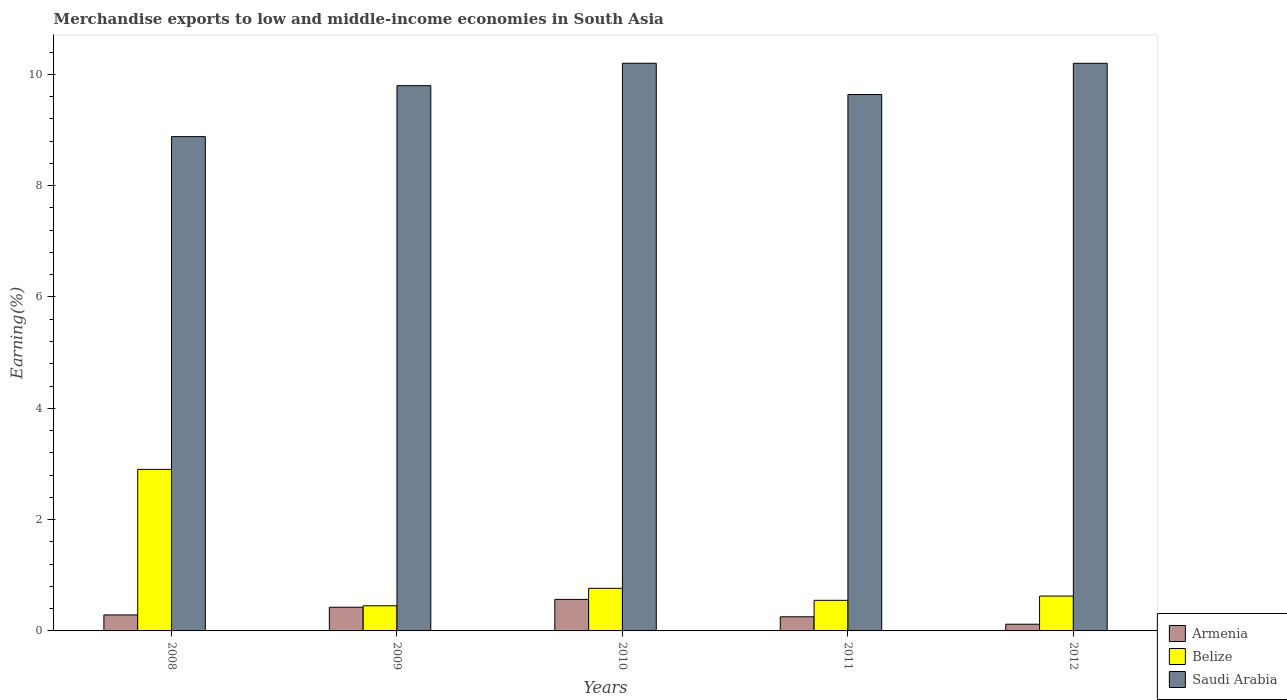Are the number of bars on each tick of the X-axis equal?
Offer a terse response. Yes. What is the label of the 3rd group of bars from the left?
Your answer should be compact. 2010. In how many cases, is the number of bars for a given year not equal to the number of legend labels?
Give a very brief answer. 0. What is the percentage of amount earned from merchandise exports in Saudi Arabia in 2008?
Make the answer very short. 8.88. Across all years, what is the maximum percentage of amount earned from merchandise exports in Armenia?
Give a very brief answer. 0.57. Across all years, what is the minimum percentage of amount earned from merchandise exports in Saudi Arabia?
Your answer should be compact. 8.88. What is the total percentage of amount earned from merchandise exports in Saudi Arabia in the graph?
Ensure brevity in your answer.  48.71. What is the difference between the percentage of amount earned from merchandise exports in Belize in 2009 and that in 2011?
Your answer should be compact. -0.1. What is the difference between the percentage of amount earned from merchandise exports in Armenia in 2010 and the percentage of amount earned from merchandise exports in Saudi Arabia in 2012?
Offer a very short reply. -9.63. What is the average percentage of amount earned from merchandise exports in Belize per year?
Provide a succinct answer. 1.06. In the year 2008, what is the difference between the percentage of amount earned from merchandise exports in Armenia and percentage of amount earned from merchandise exports in Saudi Arabia?
Provide a succinct answer. -8.59. What is the ratio of the percentage of amount earned from merchandise exports in Armenia in 2010 to that in 2011?
Your answer should be compact. 2.23. Is the percentage of amount earned from merchandise exports in Saudi Arabia in 2009 less than that in 2011?
Your response must be concise. No. What is the difference between the highest and the second highest percentage of amount earned from merchandise exports in Saudi Arabia?
Keep it short and to the point. 0. What is the difference between the highest and the lowest percentage of amount earned from merchandise exports in Belize?
Offer a terse response. 2.45. What does the 3rd bar from the left in 2011 represents?
Provide a succinct answer. Saudi Arabia. What does the 3rd bar from the right in 2009 represents?
Give a very brief answer. Armenia. Are all the bars in the graph horizontal?
Offer a terse response. No. Does the graph contain any zero values?
Give a very brief answer. No. Does the graph contain grids?
Your answer should be compact. No. Where does the legend appear in the graph?
Your answer should be very brief. Bottom right. How many legend labels are there?
Ensure brevity in your answer.  3. How are the legend labels stacked?
Offer a terse response. Vertical. What is the title of the graph?
Offer a terse response. Merchandise exports to low and middle-income economies in South Asia. Does "Slovak Republic" appear as one of the legend labels in the graph?
Your answer should be very brief. No. What is the label or title of the X-axis?
Give a very brief answer. Years. What is the label or title of the Y-axis?
Give a very brief answer. Earning(%). What is the Earning(%) in Armenia in 2008?
Keep it short and to the point. 0.29. What is the Earning(%) of Belize in 2008?
Offer a very short reply. 2.9. What is the Earning(%) of Saudi Arabia in 2008?
Provide a short and direct response. 8.88. What is the Earning(%) in Armenia in 2009?
Provide a succinct answer. 0.43. What is the Earning(%) of Belize in 2009?
Offer a very short reply. 0.45. What is the Earning(%) of Saudi Arabia in 2009?
Provide a succinct answer. 9.8. What is the Earning(%) in Armenia in 2010?
Your response must be concise. 0.57. What is the Earning(%) in Belize in 2010?
Give a very brief answer. 0.77. What is the Earning(%) of Saudi Arabia in 2010?
Your answer should be compact. 10.2. What is the Earning(%) of Armenia in 2011?
Keep it short and to the point. 0.25. What is the Earning(%) in Belize in 2011?
Provide a succinct answer. 0.55. What is the Earning(%) in Saudi Arabia in 2011?
Provide a succinct answer. 9.64. What is the Earning(%) of Armenia in 2012?
Provide a short and direct response. 0.12. What is the Earning(%) of Belize in 2012?
Keep it short and to the point. 0.63. What is the Earning(%) in Saudi Arabia in 2012?
Provide a succinct answer. 10.2. Across all years, what is the maximum Earning(%) of Armenia?
Make the answer very short. 0.57. Across all years, what is the maximum Earning(%) in Belize?
Give a very brief answer. 2.9. Across all years, what is the maximum Earning(%) of Saudi Arabia?
Your response must be concise. 10.2. Across all years, what is the minimum Earning(%) in Armenia?
Your answer should be compact. 0.12. Across all years, what is the minimum Earning(%) of Belize?
Offer a very short reply. 0.45. Across all years, what is the minimum Earning(%) of Saudi Arabia?
Offer a very short reply. 8.88. What is the total Earning(%) in Armenia in the graph?
Ensure brevity in your answer.  1.65. What is the total Earning(%) in Belize in the graph?
Make the answer very short. 5.29. What is the total Earning(%) of Saudi Arabia in the graph?
Ensure brevity in your answer.  48.71. What is the difference between the Earning(%) in Armenia in 2008 and that in 2009?
Your answer should be compact. -0.14. What is the difference between the Earning(%) in Belize in 2008 and that in 2009?
Your answer should be compact. 2.45. What is the difference between the Earning(%) of Saudi Arabia in 2008 and that in 2009?
Your response must be concise. -0.92. What is the difference between the Earning(%) of Armenia in 2008 and that in 2010?
Offer a terse response. -0.28. What is the difference between the Earning(%) of Belize in 2008 and that in 2010?
Give a very brief answer. 2.14. What is the difference between the Earning(%) in Saudi Arabia in 2008 and that in 2010?
Ensure brevity in your answer.  -1.32. What is the difference between the Earning(%) in Armenia in 2008 and that in 2011?
Offer a terse response. 0.03. What is the difference between the Earning(%) in Belize in 2008 and that in 2011?
Provide a succinct answer. 2.35. What is the difference between the Earning(%) in Saudi Arabia in 2008 and that in 2011?
Provide a succinct answer. -0.76. What is the difference between the Earning(%) of Armenia in 2008 and that in 2012?
Keep it short and to the point. 0.17. What is the difference between the Earning(%) of Belize in 2008 and that in 2012?
Make the answer very short. 2.28. What is the difference between the Earning(%) in Saudi Arabia in 2008 and that in 2012?
Your response must be concise. -1.32. What is the difference between the Earning(%) of Armenia in 2009 and that in 2010?
Your response must be concise. -0.14. What is the difference between the Earning(%) of Belize in 2009 and that in 2010?
Ensure brevity in your answer.  -0.31. What is the difference between the Earning(%) of Saudi Arabia in 2009 and that in 2010?
Provide a short and direct response. -0.4. What is the difference between the Earning(%) in Armenia in 2009 and that in 2011?
Offer a terse response. 0.17. What is the difference between the Earning(%) of Belize in 2009 and that in 2011?
Your response must be concise. -0.1. What is the difference between the Earning(%) of Saudi Arabia in 2009 and that in 2011?
Ensure brevity in your answer.  0.16. What is the difference between the Earning(%) of Armenia in 2009 and that in 2012?
Ensure brevity in your answer.  0.3. What is the difference between the Earning(%) of Belize in 2009 and that in 2012?
Offer a very short reply. -0.17. What is the difference between the Earning(%) of Saudi Arabia in 2009 and that in 2012?
Give a very brief answer. -0.4. What is the difference between the Earning(%) of Armenia in 2010 and that in 2011?
Ensure brevity in your answer.  0.31. What is the difference between the Earning(%) in Belize in 2010 and that in 2011?
Keep it short and to the point. 0.22. What is the difference between the Earning(%) of Saudi Arabia in 2010 and that in 2011?
Offer a very short reply. 0.56. What is the difference between the Earning(%) of Armenia in 2010 and that in 2012?
Provide a short and direct response. 0.45. What is the difference between the Earning(%) in Belize in 2010 and that in 2012?
Your response must be concise. 0.14. What is the difference between the Earning(%) of Saudi Arabia in 2010 and that in 2012?
Give a very brief answer. 0. What is the difference between the Earning(%) of Armenia in 2011 and that in 2012?
Offer a terse response. 0.13. What is the difference between the Earning(%) of Belize in 2011 and that in 2012?
Your answer should be very brief. -0.08. What is the difference between the Earning(%) in Saudi Arabia in 2011 and that in 2012?
Provide a succinct answer. -0.56. What is the difference between the Earning(%) of Armenia in 2008 and the Earning(%) of Belize in 2009?
Offer a very short reply. -0.16. What is the difference between the Earning(%) of Armenia in 2008 and the Earning(%) of Saudi Arabia in 2009?
Keep it short and to the point. -9.51. What is the difference between the Earning(%) in Belize in 2008 and the Earning(%) in Saudi Arabia in 2009?
Provide a short and direct response. -6.89. What is the difference between the Earning(%) in Armenia in 2008 and the Earning(%) in Belize in 2010?
Give a very brief answer. -0.48. What is the difference between the Earning(%) in Armenia in 2008 and the Earning(%) in Saudi Arabia in 2010?
Ensure brevity in your answer.  -9.91. What is the difference between the Earning(%) in Belize in 2008 and the Earning(%) in Saudi Arabia in 2010?
Offer a terse response. -7.3. What is the difference between the Earning(%) in Armenia in 2008 and the Earning(%) in Belize in 2011?
Make the answer very short. -0.26. What is the difference between the Earning(%) of Armenia in 2008 and the Earning(%) of Saudi Arabia in 2011?
Keep it short and to the point. -9.35. What is the difference between the Earning(%) in Belize in 2008 and the Earning(%) in Saudi Arabia in 2011?
Provide a short and direct response. -6.73. What is the difference between the Earning(%) of Armenia in 2008 and the Earning(%) of Belize in 2012?
Keep it short and to the point. -0.34. What is the difference between the Earning(%) in Armenia in 2008 and the Earning(%) in Saudi Arabia in 2012?
Your answer should be compact. -9.91. What is the difference between the Earning(%) of Belize in 2008 and the Earning(%) of Saudi Arabia in 2012?
Your response must be concise. -7.3. What is the difference between the Earning(%) of Armenia in 2009 and the Earning(%) of Belize in 2010?
Your response must be concise. -0.34. What is the difference between the Earning(%) of Armenia in 2009 and the Earning(%) of Saudi Arabia in 2010?
Your answer should be very brief. -9.77. What is the difference between the Earning(%) of Belize in 2009 and the Earning(%) of Saudi Arabia in 2010?
Your response must be concise. -9.75. What is the difference between the Earning(%) of Armenia in 2009 and the Earning(%) of Belize in 2011?
Your response must be concise. -0.12. What is the difference between the Earning(%) in Armenia in 2009 and the Earning(%) in Saudi Arabia in 2011?
Ensure brevity in your answer.  -9.21. What is the difference between the Earning(%) in Belize in 2009 and the Earning(%) in Saudi Arabia in 2011?
Give a very brief answer. -9.19. What is the difference between the Earning(%) of Armenia in 2009 and the Earning(%) of Belize in 2012?
Give a very brief answer. -0.2. What is the difference between the Earning(%) in Armenia in 2009 and the Earning(%) in Saudi Arabia in 2012?
Make the answer very short. -9.77. What is the difference between the Earning(%) of Belize in 2009 and the Earning(%) of Saudi Arabia in 2012?
Your response must be concise. -9.75. What is the difference between the Earning(%) in Armenia in 2010 and the Earning(%) in Belize in 2011?
Offer a terse response. 0.02. What is the difference between the Earning(%) in Armenia in 2010 and the Earning(%) in Saudi Arabia in 2011?
Your response must be concise. -9.07. What is the difference between the Earning(%) of Belize in 2010 and the Earning(%) of Saudi Arabia in 2011?
Offer a very short reply. -8.87. What is the difference between the Earning(%) in Armenia in 2010 and the Earning(%) in Belize in 2012?
Offer a very short reply. -0.06. What is the difference between the Earning(%) of Armenia in 2010 and the Earning(%) of Saudi Arabia in 2012?
Offer a very short reply. -9.63. What is the difference between the Earning(%) of Belize in 2010 and the Earning(%) of Saudi Arabia in 2012?
Your answer should be compact. -9.43. What is the difference between the Earning(%) in Armenia in 2011 and the Earning(%) in Belize in 2012?
Keep it short and to the point. -0.37. What is the difference between the Earning(%) in Armenia in 2011 and the Earning(%) in Saudi Arabia in 2012?
Provide a succinct answer. -9.94. What is the difference between the Earning(%) of Belize in 2011 and the Earning(%) of Saudi Arabia in 2012?
Provide a short and direct response. -9.65. What is the average Earning(%) in Armenia per year?
Offer a very short reply. 0.33. What is the average Earning(%) in Belize per year?
Make the answer very short. 1.06. What is the average Earning(%) in Saudi Arabia per year?
Offer a very short reply. 9.74. In the year 2008, what is the difference between the Earning(%) of Armenia and Earning(%) of Belize?
Your answer should be compact. -2.61. In the year 2008, what is the difference between the Earning(%) in Armenia and Earning(%) in Saudi Arabia?
Your response must be concise. -8.59. In the year 2008, what is the difference between the Earning(%) in Belize and Earning(%) in Saudi Arabia?
Offer a very short reply. -5.98. In the year 2009, what is the difference between the Earning(%) in Armenia and Earning(%) in Belize?
Offer a terse response. -0.03. In the year 2009, what is the difference between the Earning(%) of Armenia and Earning(%) of Saudi Arabia?
Keep it short and to the point. -9.37. In the year 2009, what is the difference between the Earning(%) of Belize and Earning(%) of Saudi Arabia?
Keep it short and to the point. -9.34. In the year 2010, what is the difference between the Earning(%) of Armenia and Earning(%) of Belize?
Ensure brevity in your answer.  -0.2. In the year 2010, what is the difference between the Earning(%) of Armenia and Earning(%) of Saudi Arabia?
Provide a short and direct response. -9.63. In the year 2010, what is the difference between the Earning(%) of Belize and Earning(%) of Saudi Arabia?
Provide a succinct answer. -9.43. In the year 2011, what is the difference between the Earning(%) of Armenia and Earning(%) of Belize?
Provide a succinct answer. -0.3. In the year 2011, what is the difference between the Earning(%) of Armenia and Earning(%) of Saudi Arabia?
Provide a short and direct response. -9.38. In the year 2011, what is the difference between the Earning(%) in Belize and Earning(%) in Saudi Arabia?
Your response must be concise. -9.09. In the year 2012, what is the difference between the Earning(%) in Armenia and Earning(%) in Belize?
Your response must be concise. -0.51. In the year 2012, what is the difference between the Earning(%) of Armenia and Earning(%) of Saudi Arabia?
Provide a succinct answer. -10.08. In the year 2012, what is the difference between the Earning(%) in Belize and Earning(%) in Saudi Arabia?
Offer a terse response. -9.57. What is the ratio of the Earning(%) of Armenia in 2008 to that in 2009?
Offer a terse response. 0.67. What is the ratio of the Earning(%) in Belize in 2008 to that in 2009?
Your answer should be very brief. 6.43. What is the ratio of the Earning(%) of Saudi Arabia in 2008 to that in 2009?
Offer a terse response. 0.91. What is the ratio of the Earning(%) in Armenia in 2008 to that in 2010?
Your response must be concise. 0.51. What is the ratio of the Earning(%) in Belize in 2008 to that in 2010?
Give a very brief answer. 3.79. What is the ratio of the Earning(%) in Saudi Arabia in 2008 to that in 2010?
Provide a succinct answer. 0.87. What is the ratio of the Earning(%) in Armenia in 2008 to that in 2011?
Offer a very short reply. 1.13. What is the ratio of the Earning(%) in Belize in 2008 to that in 2011?
Your response must be concise. 5.28. What is the ratio of the Earning(%) of Saudi Arabia in 2008 to that in 2011?
Provide a succinct answer. 0.92. What is the ratio of the Earning(%) in Armenia in 2008 to that in 2012?
Your answer should be compact. 2.38. What is the ratio of the Earning(%) in Belize in 2008 to that in 2012?
Your answer should be compact. 4.63. What is the ratio of the Earning(%) of Saudi Arabia in 2008 to that in 2012?
Provide a short and direct response. 0.87. What is the ratio of the Earning(%) of Armenia in 2009 to that in 2010?
Ensure brevity in your answer.  0.75. What is the ratio of the Earning(%) in Belize in 2009 to that in 2010?
Keep it short and to the point. 0.59. What is the ratio of the Earning(%) of Saudi Arabia in 2009 to that in 2010?
Your response must be concise. 0.96. What is the ratio of the Earning(%) of Armenia in 2009 to that in 2011?
Give a very brief answer. 1.68. What is the ratio of the Earning(%) in Belize in 2009 to that in 2011?
Ensure brevity in your answer.  0.82. What is the ratio of the Earning(%) in Saudi Arabia in 2009 to that in 2011?
Offer a very short reply. 1.02. What is the ratio of the Earning(%) of Armenia in 2009 to that in 2012?
Give a very brief answer. 3.53. What is the ratio of the Earning(%) in Belize in 2009 to that in 2012?
Ensure brevity in your answer.  0.72. What is the ratio of the Earning(%) of Saudi Arabia in 2009 to that in 2012?
Your answer should be compact. 0.96. What is the ratio of the Earning(%) of Armenia in 2010 to that in 2011?
Your answer should be very brief. 2.23. What is the ratio of the Earning(%) of Belize in 2010 to that in 2011?
Ensure brevity in your answer.  1.39. What is the ratio of the Earning(%) of Saudi Arabia in 2010 to that in 2011?
Ensure brevity in your answer.  1.06. What is the ratio of the Earning(%) of Armenia in 2010 to that in 2012?
Offer a terse response. 4.7. What is the ratio of the Earning(%) of Belize in 2010 to that in 2012?
Make the answer very short. 1.22. What is the ratio of the Earning(%) in Armenia in 2011 to that in 2012?
Give a very brief answer. 2.11. What is the ratio of the Earning(%) in Belize in 2011 to that in 2012?
Offer a very short reply. 0.88. What is the ratio of the Earning(%) in Saudi Arabia in 2011 to that in 2012?
Give a very brief answer. 0.94. What is the difference between the highest and the second highest Earning(%) of Armenia?
Your response must be concise. 0.14. What is the difference between the highest and the second highest Earning(%) of Belize?
Provide a succinct answer. 2.14. What is the difference between the highest and the second highest Earning(%) of Saudi Arabia?
Provide a short and direct response. 0. What is the difference between the highest and the lowest Earning(%) in Armenia?
Offer a terse response. 0.45. What is the difference between the highest and the lowest Earning(%) in Belize?
Ensure brevity in your answer.  2.45. What is the difference between the highest and the lowest Earning(%) in Saudi Arabia?
Keep it short and to the point. 1.32. 